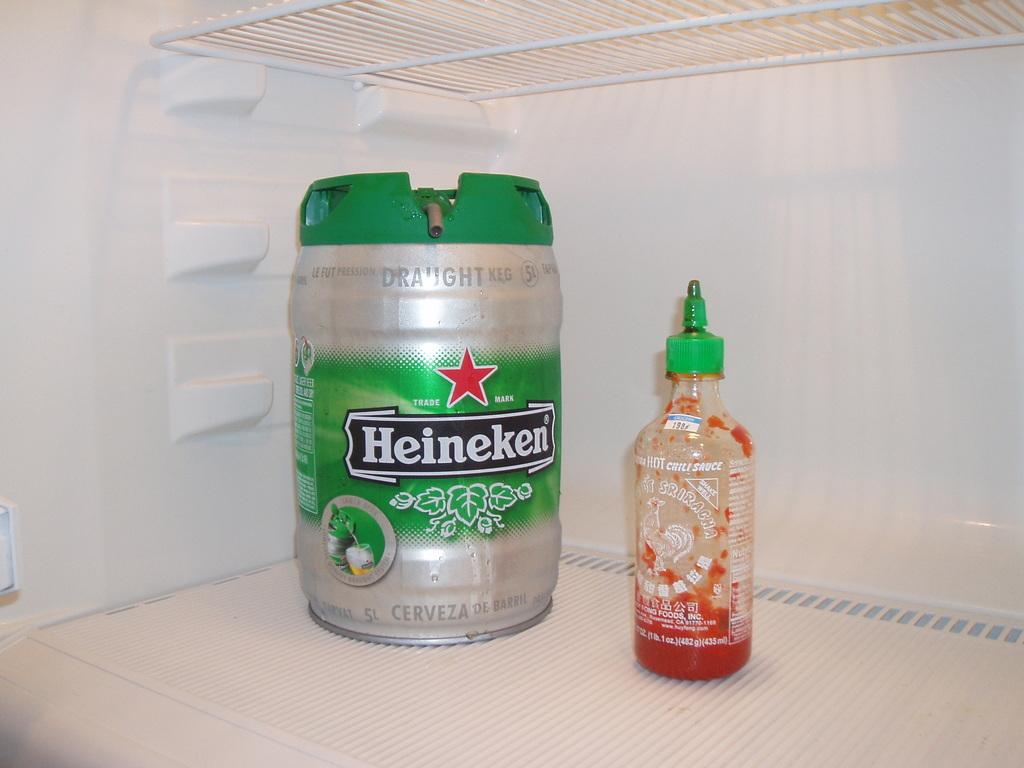<image>
Offer a succinct explanation of the picture presented. A keg of Heineken in a fridge next to a sauce bottle. 